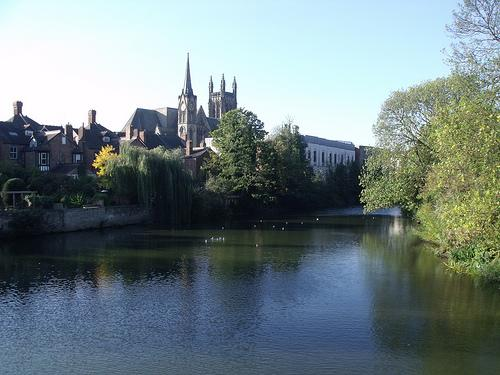What is the color of the water and its state in the image? The water is clear and calm, with green reflections from the surrounding environment. What is the sentiment expressed in the image? The sentiment expressed in the image is calm and serene, as it depicts a peaceful riverside town scene with clear skies and calm water. What type of birds are on the water and how many are there? There are small white birds on the water, but the number is not specified. Identify the main elements of the scene in the image. A riverside town scene with a group of homes, green trees, clear sky, and a calm body of water that reflects the surroundings. Briefly describe the appearance of the trees in the image. There is a group of green trees, a tall green tree on the river bank, a tree with yellow leaves, and a willow tree hanging over the river. Count the total number of buildings mentioned in the image description. Six buildings are mentioned in the image description. What kind of weather is depicted in the image? The weather is clear with little clouds in the sky. 